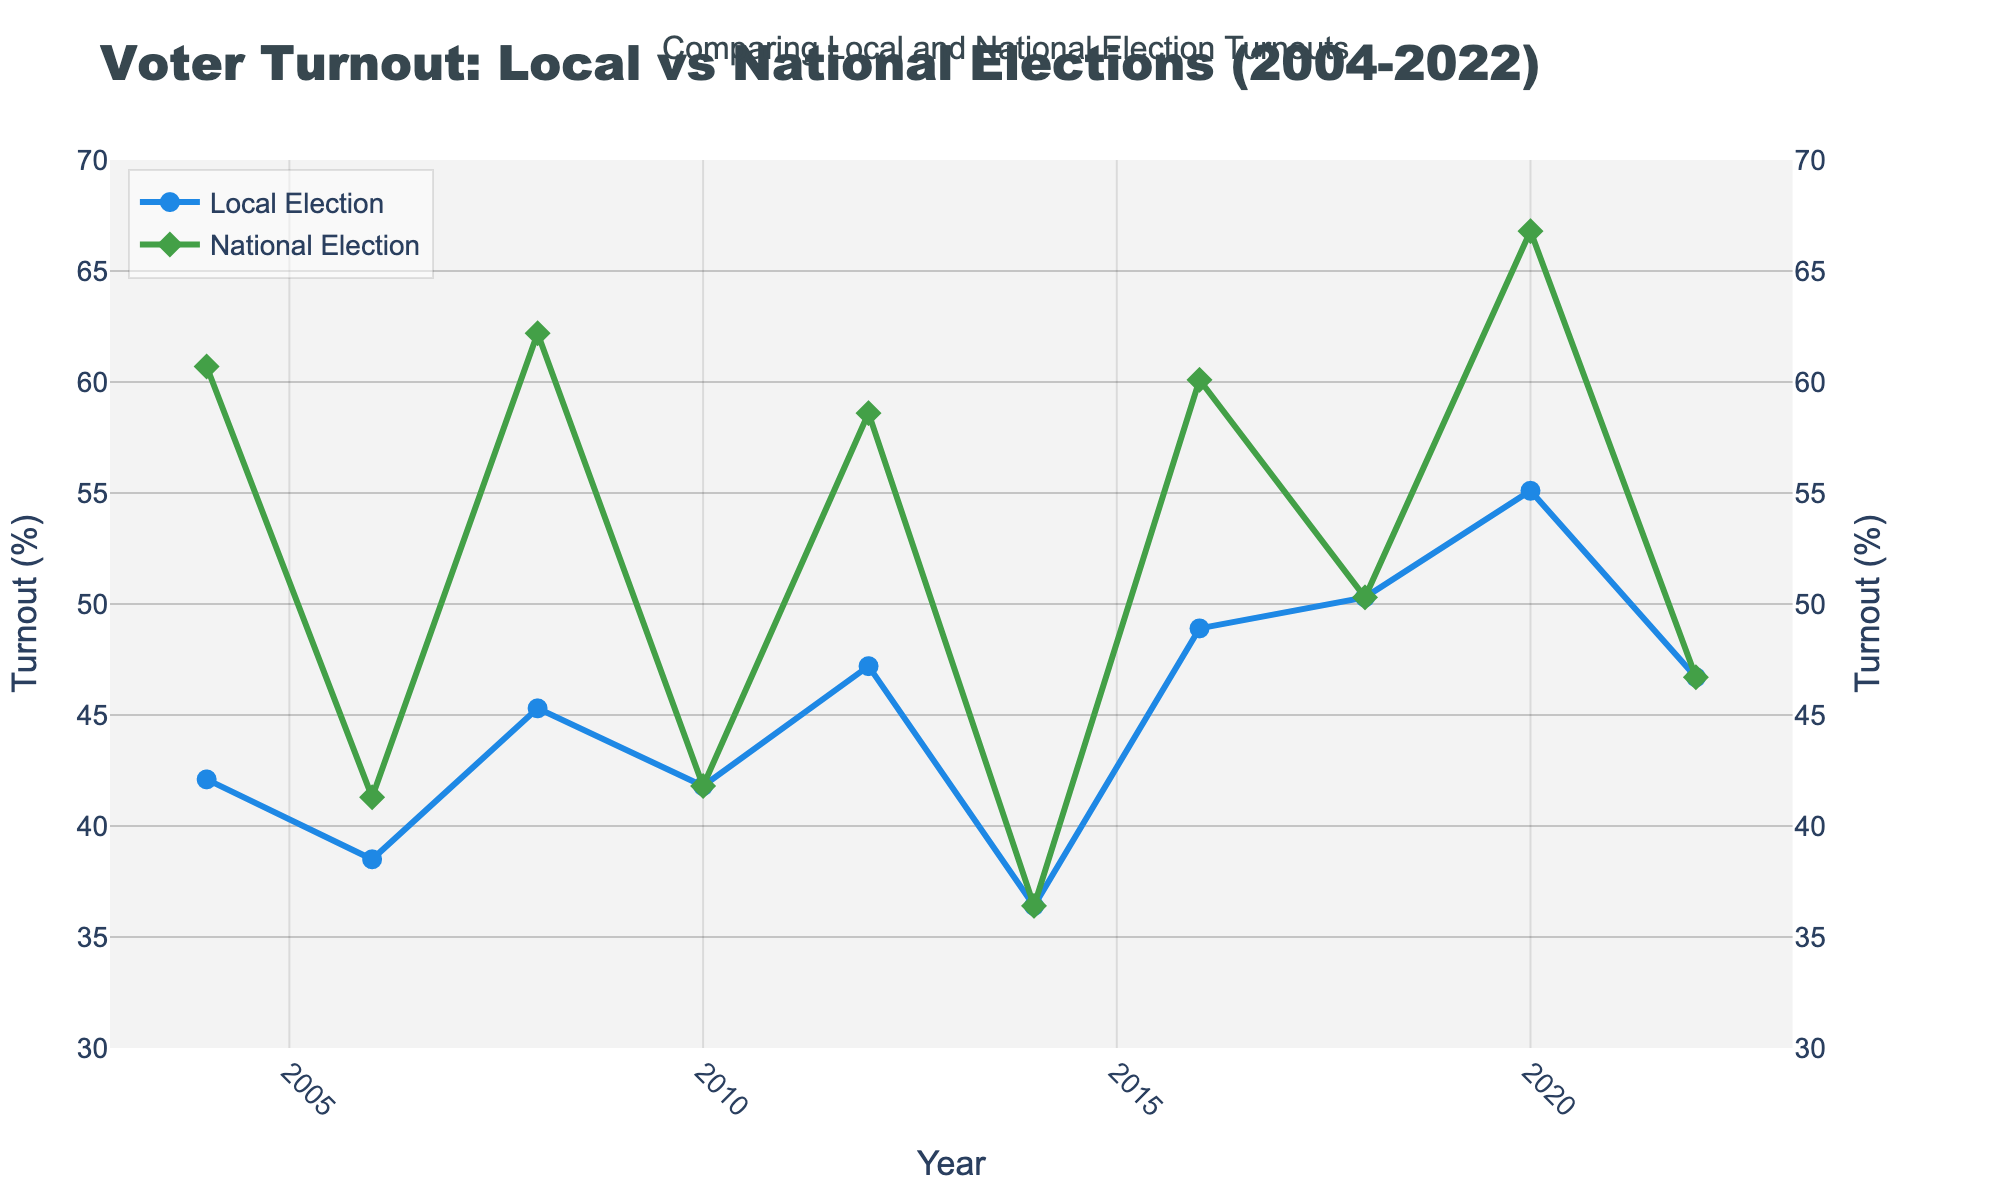Which year had the highest voter turnout for local elections? From the figure, it is evident that the peak in the local election turnout line (blue line) occurred in 2020.
Answer: 2020 In which year were the voter turnouts for local and national elections equal? The figure shows that in the years 2010, 2014, and 2022, the lines for local and national turnout intersect, indicating equal turnouts.
Answer: 2010, 2014, 2022 What's the difference in voter turnout between local and national elections in 2016? Refer to the points for 2016 on the figure: National Election Turnout is about 60.1%, and Local Election Turnout is around 48.9%. The difference is 60.1 - 48.9.
Answer: 11.2% Which election type had a more significant increase in voter turnout between 2014 and 2020? Look at the change in turnout for both elections between 2014 and 2020: Local increased from 36.4% to 55.1%, National increased from 36.4% to 66.8%. The absolute increase for Local is 55.1 - 36.4 and for National is 66.8 - 36.4.
Answer: National elections What's the average voter turnout for local elections from 2004 to 2022? Sum the voter turnouts for local elections from each year, then divide by the number of years (10): (42.1 + 38.5 + 45.3 + 41.8 + 47.2 + 36.4 + 48.9 + 50.3 + 55.1 + 46.7)/10.
Answer: 45.23% By how much did voter turnout in local elections increase from 2018 to 2020? Analyze the local election turnout in these years: it was 50.3% in 2018 and 55.1% in 2020. The increase is 55.1 - 50.3.
Answer: 4.8% How many years show higher voter turnout in national elections compared to local elections? Count the years where the green line (national turnout) is above the blue line (local turnout): 2004, 2008, 2012, 2016, 2020.
Answer: 5 years Describe the trend of local election turnout over the 20 years. The blue line shows a general increasing trend in voter turnout for local elections from 2004 with notable fluctuations.
Answer: Increasing with fluctuations 